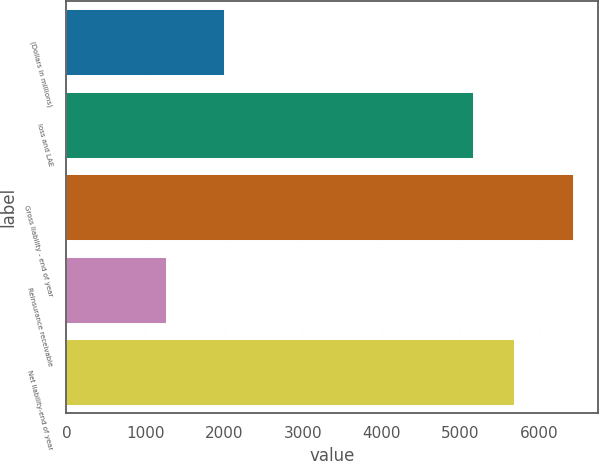Convert chart to OTSL. <chart><loc_0><loc_0><loc_500><loc_500><bar_chart><fcel>(Dollars in millions)<fcel>loss and LAE<fcel>Gross liability - end of year<fcel>Reinsurance receivable<fcel>Net liability-end of year<nl><fcel>2003<fcel>5158.4<fcel>6424.7<fcel>1266.3<fcel>5674.24<nl></chart> 